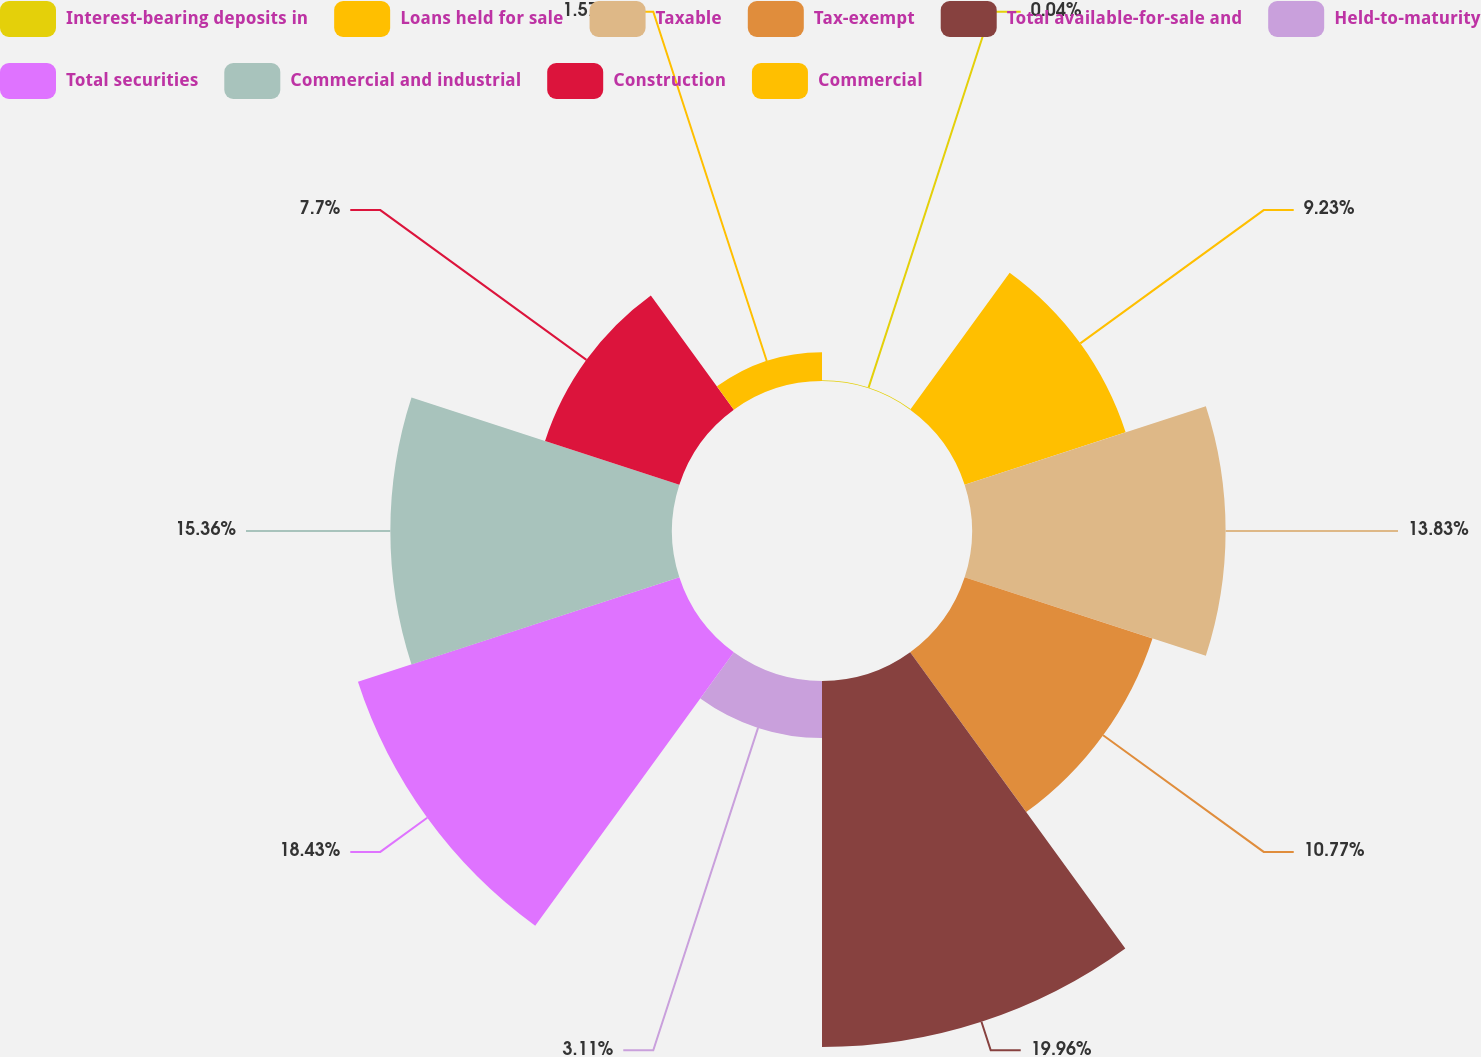Convert chart. <chart><loc_0><loc_0><loc_500><loc_500><pie_chart><fcel>Interest-bearing deposits in<fcel>Loans held for sale<fcel>Taxable<fcel>Tax-exempt<fcel>Total available-for-sale and<fcel>Held-to-maturity<fcel>Total securities<fcel>Commercial and industrial<fcel>Construction<fcel>Commercial<nl><fcel>0.04%<fcel>9.23%<fcel>13.83%<fcel>10.77%<fcel>19.96%<fcel>3.11%<fcel>18.43%<fcel>15.36%<fcel>7.7%<fcel>1.57%<nl></chart> 